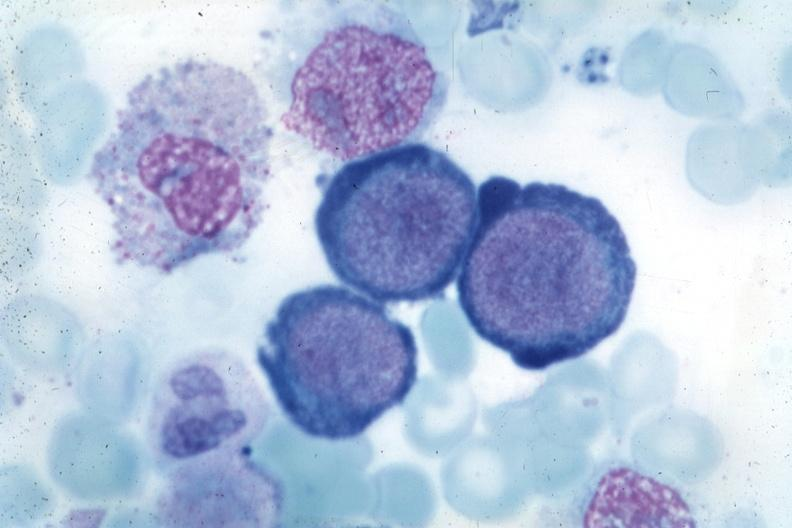s hematologic present?
Answer the question using a single word or phrase. Yes 